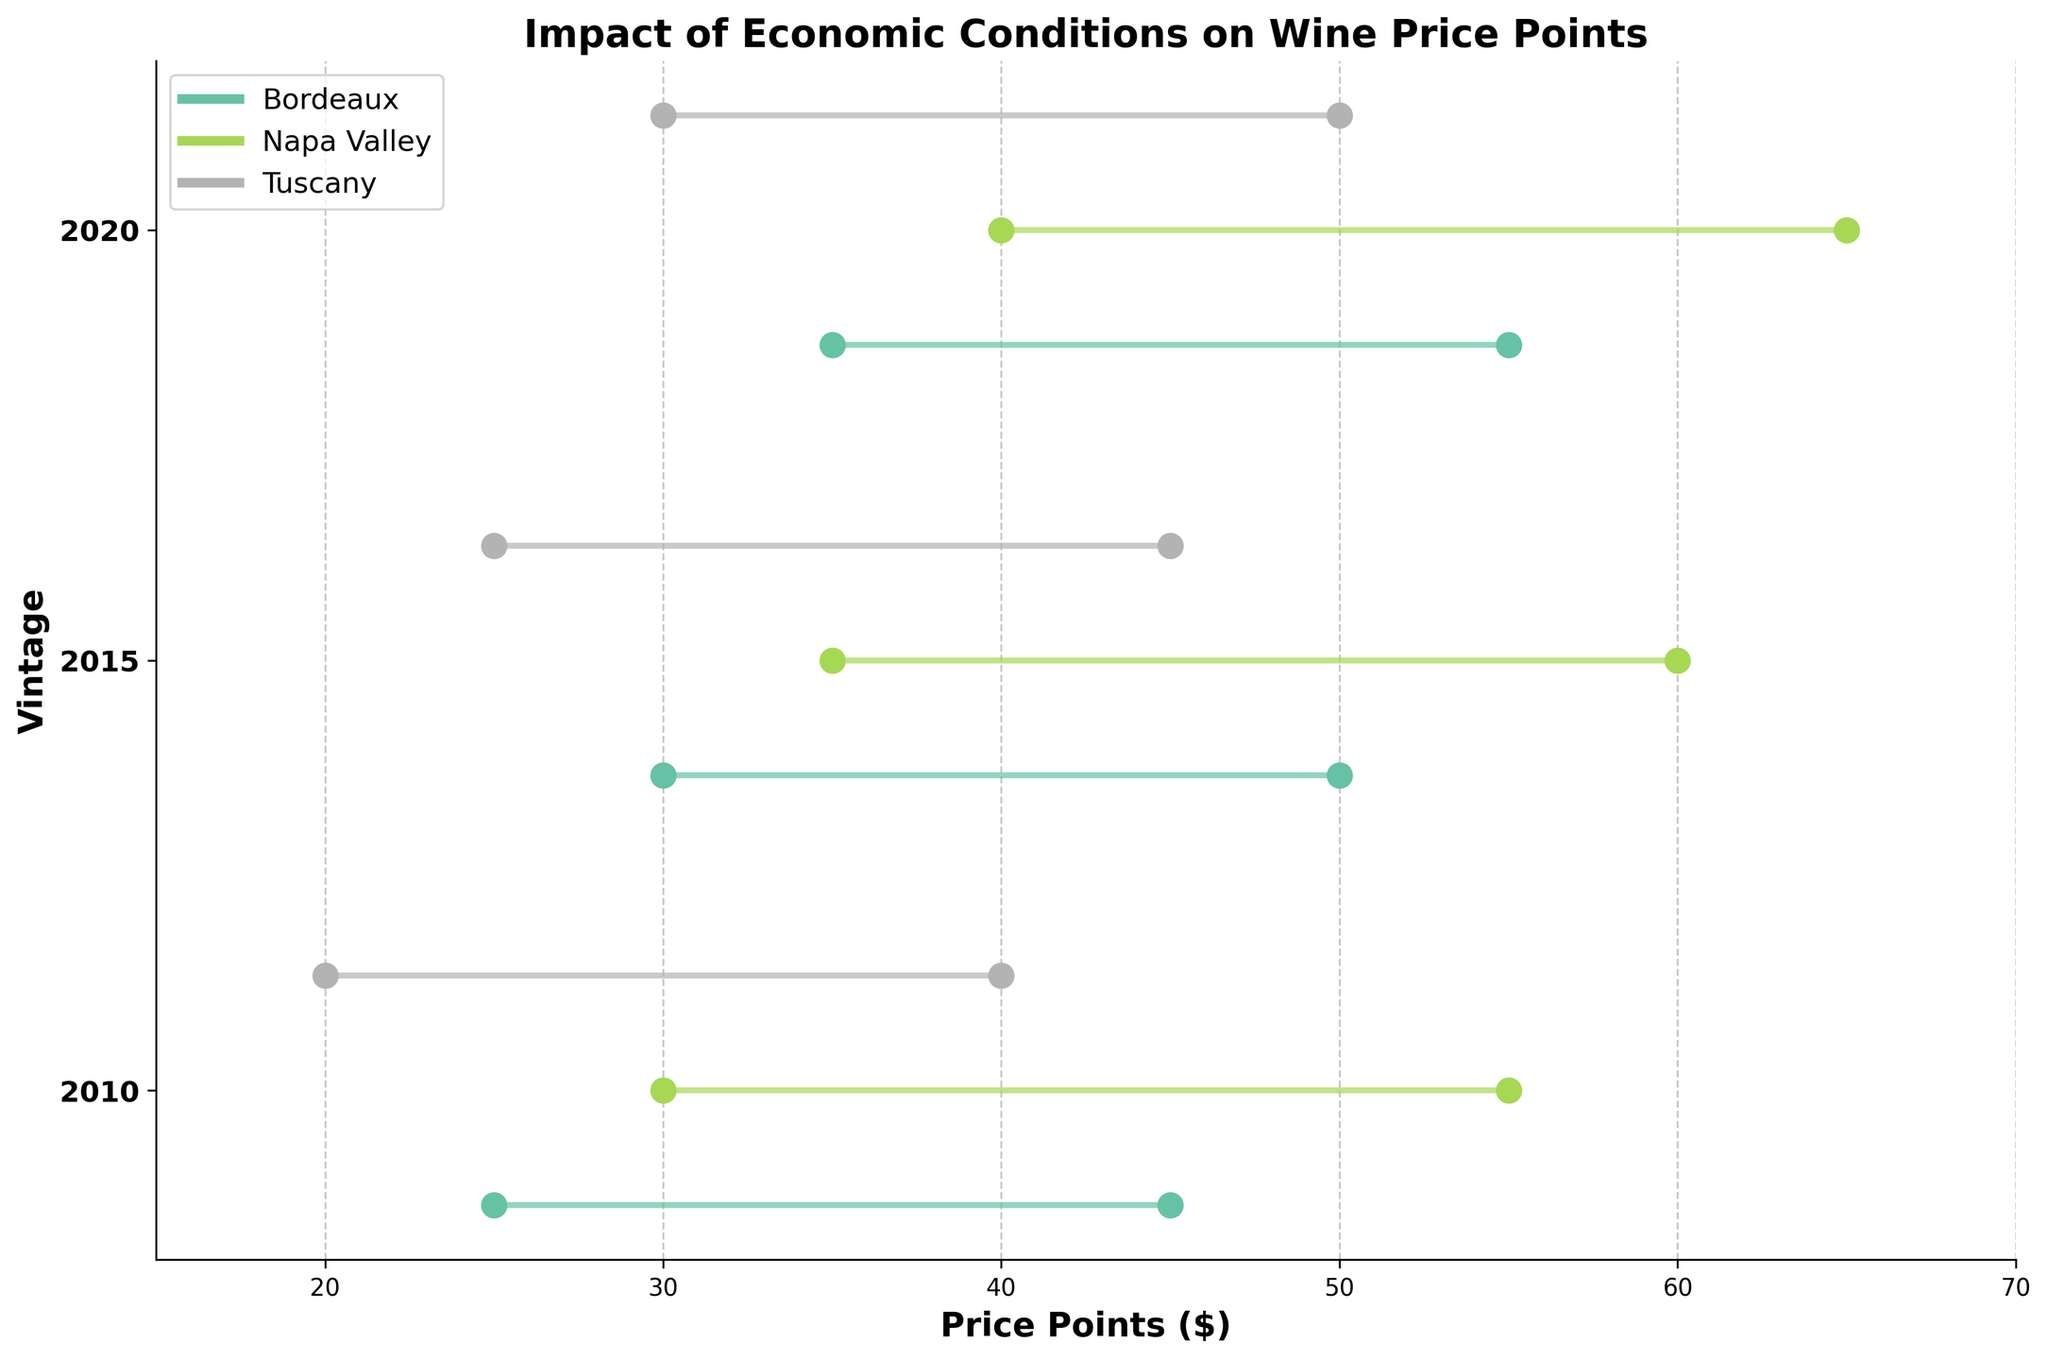What's the title of the figure? The title of the figure is typically displayed at the top of the plot. Here, it is directly mentioned in the generate_plot function as 'Impact of Economic Conditions on Wine Price Points'.
Answer: Impact of Economic Conditions on Wine Price Points Which region had the highest price point in 2020 under high economic conditions? To find the highest price point in 2020 under high economic conditions, look for the maximum value in the 'High Economic Conditions' column for the year 2020. From the data, Napa Valley with a price point of 65 has the highest value.
Answer: Napa Valley What's the range of price points for Tuscany in 2015? The range is calculated as the difference between the highest and lowest price points. For Tuscany in 2015, the low economic condition price is 25, and the high economic condition price is 45. So, the range is 45 - 25 = 20.
Answer: 20 Which vintage year shows the smallest price difference between low and high economic conditions in Bordeaux? Calculate the price differences for each vintage year in Bordeaux by subtracting the 'Low Economic Conditions' from 'High Economic Conditions'. For 2010: 45-25=20, for 2015: 50-30=20, and for 2020: 55-35=20. They all have the same difference of 20.
Answer: 2010, 2015, 2020 What was the average wine price in Napa Valley in low economic conditions across all vintages? To find the average price, sum the 'Low Economic Conditions' prices for all vintages in Napa Valley and divide by the number of vintages. (30 + 35 + 40) / 3 = 105 / 3 = 35.
Answer: 35 Which region shows the greatest increase in price points from 2010 to 2020 under low economic conditions? Calculate the difference in 'Low Economic Conditions' prices from 2010 to 2020 for each region: Bordeaux: 35-25=10, Napa Valley: 40-30=10, Tuscany: 30-20=10. They all have the same increase of 10.
Answer: All regions How do the price points of Bordeaux in low and high economic conditions in 2015 compare? Compare the values directly. In 2015, Bordeaux has 'Low Economic Conditions' price of 30 and 'High Economic Conditions' price of 50. The high economic condition price is 20 units higher.
Answer: High > Low by 20 Which vintage year shows the smallest difference in price points between regions in high economic conditions? For each year, find the range of prices under high economic conditions, and compare. 2010: max(45, 55, 40) - min(45, 55, 40) = 15. 2015: max(50, 60, 45) - min(50, 60, 45) = 15. 2020: max(55, 65, 50) - min(55, 65, 50) = 15. They all have the same difference of 15.
Answer: 2010, 2015, 2020 